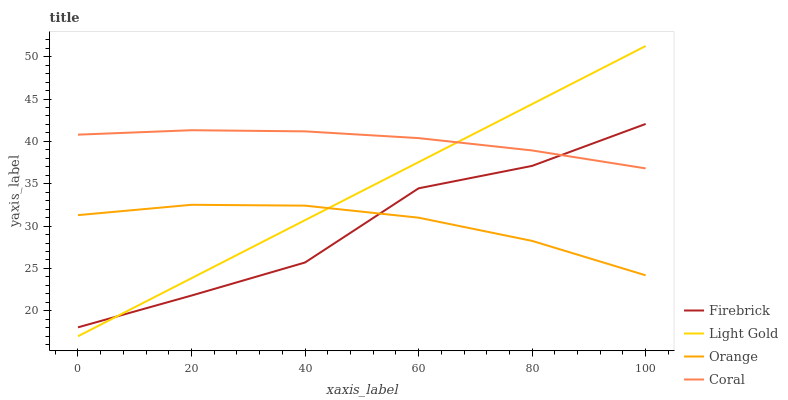Does Light Gold have the minimum area under the curve?
Answer yes or no. No. Does Light Gold have the maximum area under the curve?
Answer yes or no. No. Is Firebrick the smoothest?
Answer yes or no. No. Is Light Gold the roughest?
Answer yes or no. No. Does Firebrick have the lowest value?
Answer yes or no. No. Does Firebrick have the highest value?
Answer yes or no. No. Is Orange less than Coral?
Answer yes or no. Yes. Is Coral greater than Orange?
Answer yes or no. Yes. Does Orange intersect Coral?
Answer yes or no. No. 